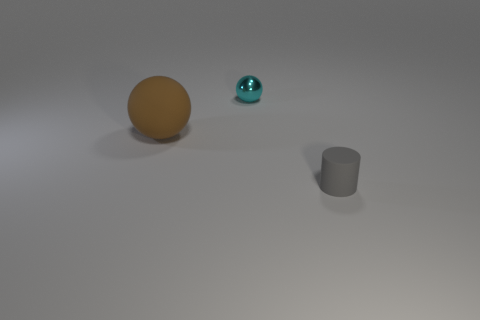What number of things are small cyan balls or tiny things that are behind the small gray thing?
Make the answer very short. 1. Is the number of balls behind the cyan metallic sphere less than the number of small gray matte things that are behind the big brown rubber sphere?
Offer a very short reply. No. How many other things are made of the same material as the cyan thing?
Your answer should be very brief. 0. Is the color of the rubber thing that is on the left side of the tiny gray rubber thing the same as the small cylinder?
Your response must be concise. No. There is a sphere that is in front of the cyan thing; is there a small cyan object that is in front of it?
Your answer should be very brief. No. There is a object that is both behind the tiny matte cylinder and in front of the cyan object; what is its material?
Provide a short and direct response. Rubber. What is the shape of the thing that is the same material as the brown sphere?
Ensure brevity in your answer.  Cylinder. Is there anything else that has the same shape as the metal object?
Your response must be concise. Yes. Do the sphere behind the large rubber sphere and the tiny gray cylinder have the same material?
Give a very brief answer. No. What is the thing on the right side of the cyan sphere made of?
Ensure brevity in your answer.  Rubber. 